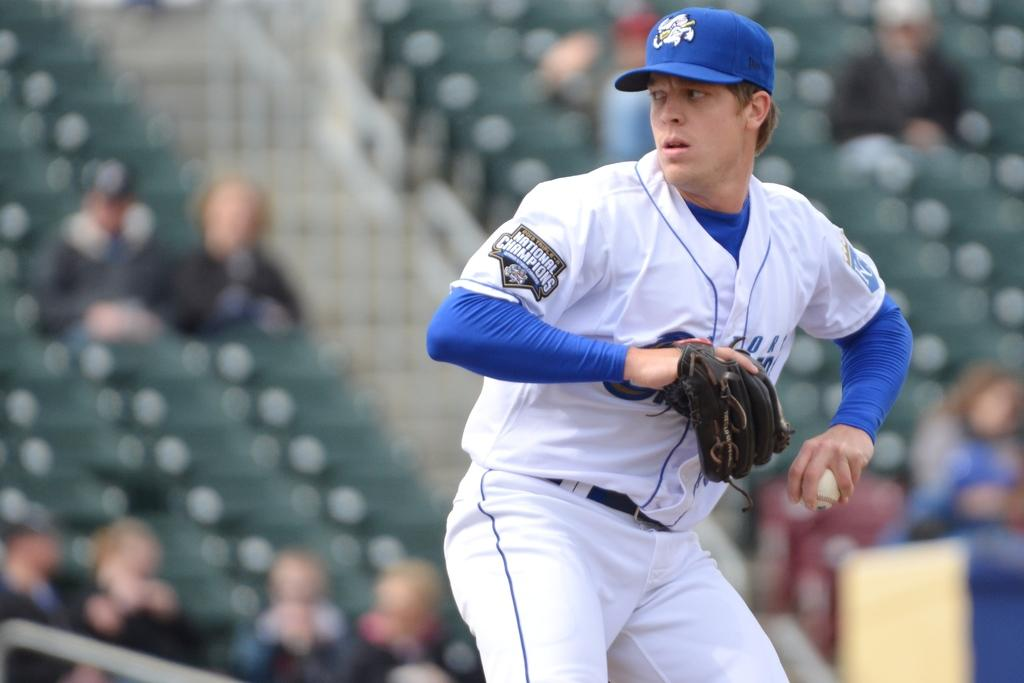<image>
Relay a brief, clear account of the picture shown. A patch on a player's uniform commemorates the 2013 Triple-A National Championships. 